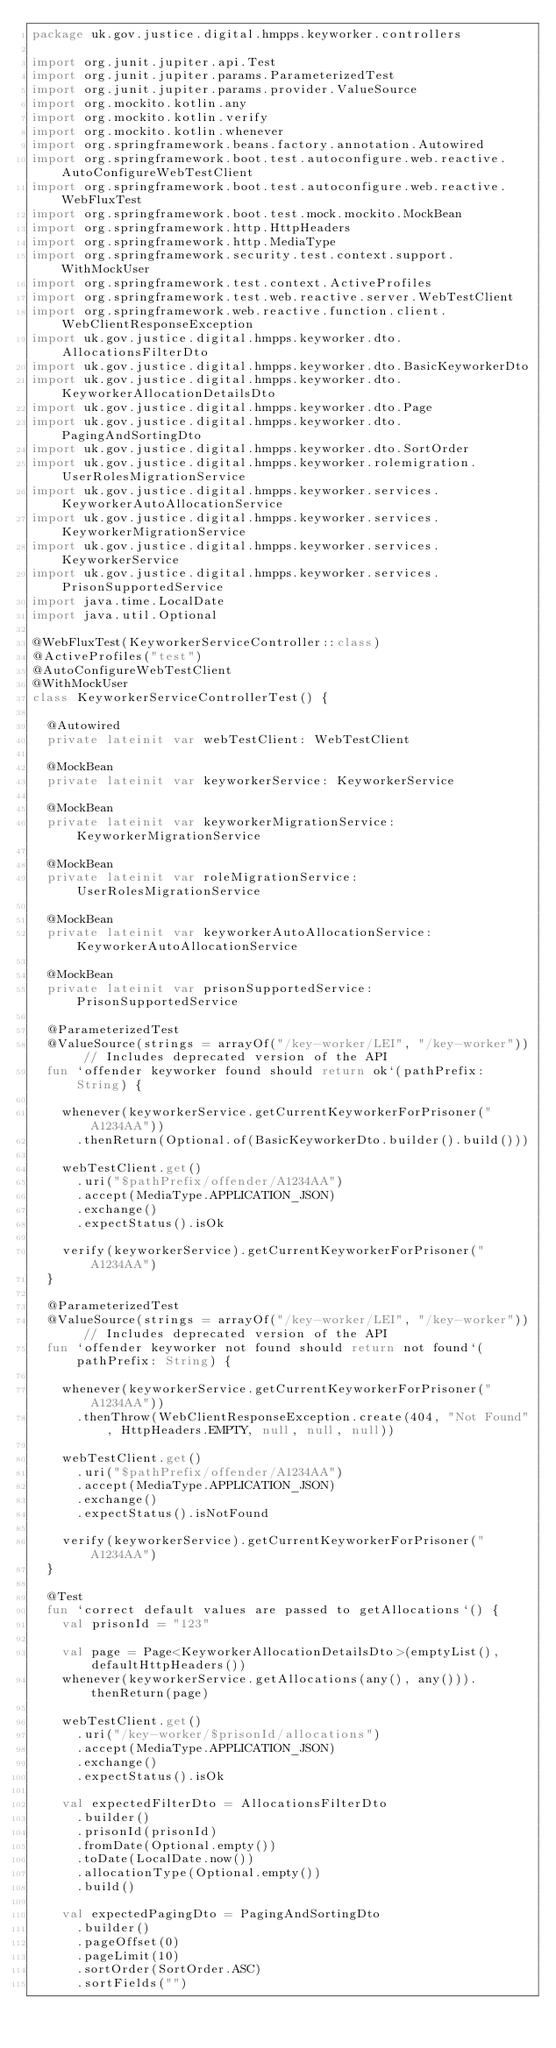<code> <loc_0><loc_0><loc_500><loc_500><_Kotlin_>package uk.gov.justice.digital.hmpps.keyworker.controllers

import org.junit.jupiter.api.Test
import org.junit.jupiter.params.ParameterizedTest
import org.junit.jupiter.params.provider.ValueSource
import org.mockito.kotlin.any
import org.mockito.kotlin.verify
import org.mockito.kotlin.whenever
import org.springframework.beans.factory.annotation.Autowired
import org.springframework.boot.test.autoconfigure.web.reactive.AutoConfigureWebTestClient
import org.springframework.boot.test.autoconfigure.web.reactive.WebFluxTest
import org.springframework.boot.test.mock.mockito.MockBean
import org.springframework.http.HttpHeaders
import org.springframework.http.MediaType
import org.springframework.security.test.context.support.WithMockUser
import org.springframework.test.context.ActiveProfiles
import org.springframework.test.web.reactive.server.WebTestClient
import org.springframework.web.reactive.function.client.WebClientResponseException
import uk.gov.justice.digital.hmpps.keyworker.dto.AllocationsFilterDto
import uk.gov.justice.digital.hmpps.keyworker.dto.BasicKeyworkerDto
import uk.gov.justice.digital.hmpps.keyworker.dto.KeyworkerAllocationDetailsDto
import uk.gov.justice.digital.hmpps.keyworker.dto.Page
import uk.gov.justice.digital.hmpps.keyworker.dto.PagingAndSortingDto
import uk.gov.justice.digital.hmpps.keyworker.dto.SortOrder
import uk.gov.justice.digital.hmpps.keyworker.rolemigration.UserRolesMigrationService
import uk.gov.justice.digital.hmpps.keyworker.services.KeyworkerAutoAllocationService
import uk.gov.justice.digital.hmpps.keyworker.services.KeyworkerMigrationService
import uk.gov.justice.digital.hmpps.keyworker.services.KeyworkerService
import uk.gov.justice.digital.hmpps.keyworker.services.PrisonSupportedService
import java.time.LocalDate
import java.util.Optional

@WebFluxTest(KeyworkerServiceController::class)
@ActiveProfiles("test")
@AutoConfigureWebTestClient
@WithMockUser
class KeyworkerServiceControllerTest() {

  @Autowired
  private lateinit var webTestClient: WebTestClient

  @MockBean
  private lateinit var keyworkerService: KeyworkerService

  @MockBean
  private lateinit var keyworkerMigrationService: KeyworkerMigrationService

  @MockBean
  private lateinit var roleMigrationService: UserRolesMigrationService

  @MockBean
  private lateinit var keyworkerAutoAllocationService: KeyworkerAutoAllocationService

  @MockBean
  private lateinit var prisonSupportedService: PrisonSupportedService

  @ParameterizedTest
  @ValueSource(strings = arrayOf("/key-worker/LEI", "/key-worker")) // Includes deprecated version of the API
  fun `offender keyworker found should return ok`(pathPrefix: String) {

    whenever(keyworkerService.getCurrentKeyworkerForPrisoner("A1234AA"))
      .thenReturn(Optional.of(BasicKeyworkerDto.builder().build()))

    webTestClient.get()
      .uri("$pathPrefix/offender/A1234AA")
      .accept(MediaType.APPLICATION_JSON)
      .exchange()
      .expectStatus().isOk

    verify(keyworkerService).getCurrentKeyworkerForPrisoner("A1234AA")
  }

  @ParameterizedTest
  @ValueSource(strings = arrayOf("/key-worker/LEI", "/key-worker")) // Includes deprecated version of the API
  fun `offender keyworker not found should return not found`(pathPrefix: String) {

    whenever(keyworkerService.getCurrentKeyworkerForPrisoner("A1234AA"))
      .thenThrow(WebClientResponseException.create(404, "Not Found", HttpHeaders.EMPTY, null, null, null))

    webTestClient.get()
      .uri("$pathPrefix/offender/A1234AA")
      .accept(MediaType.APPLICATION_JSON)
      .exchange()
      .expectStatus().isNotFound

    verify(keyworkerService).getCurrentKeyworkerForPrisoner("A1234AA")
  }

  @Test
  fun `correct default values are passed to getAllocations`() {
    val prisonId = "123"

    val page = Page<KeyworkerAllocationDetailsDto>(emptyList(), defaultHttpHeaders())
    whenever(keyworkerService.getAllocations(any(), any())).thenReturn(page)

    webTestClient.get()
      .uri("/key-worker/$prisonId/allocations")
      .accept(MediaType.APPLICATION_JSON)
      .exchange()
      .expectStatus().isOk

    val expectedFilterDto = AllocationsFilterDto
      .builder()
      .prisonId(prisonId)
      .fromDate(Optional.empty())
      .toDate(LocalDate.now())
      .allocationType(Optional.empty())
      .build()

    val expectedPagingDto = PagingAndSortingDto
      .builder()
      .pageOffset(0)
      .pageLimit(10)
      .sortOrder(SortOrder.ASC)
      .sortFields("")</code> 